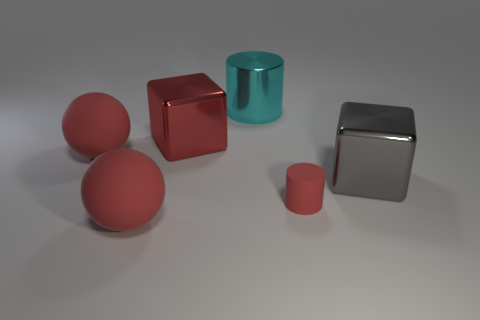What number of objects are either blocks that are to the right of the big cyan cylinder or metal things that are on the left side of the red cylinder?
Provide a succinct answer. 3. Does the cylinder behind the small red cylinder have the same material as the big red block?
Provide a succinct answer. Yes. There is a large red object that is to the left of the red metal thing and behind the large gray metal object; what is its material?
Your answer should be compact. Rubber. There is a large block in front of the big rubber ball behind the gray thing; what color is it?
Offer a terse response. Gray. What material is the gray object that is the same shape as the big red shiny thing?
Ensure brevity in your answer.  Metal. What color is the metal thing in front of the block that is behind the matte object behind the small matte thing?
Make the answer very short. Gray. What number of objects are gray metal blocks or red shiny cubes?
Your answer should be compact. 2. How many tiny red matte things have the same shape as the cyan metallic thing?
Provide a short and direct response. 1. Is the material of the gray object the same as the red object that is in front of the small cylinder?
Make the answer very short. No. There is a gray object that is made of the same material as the large cyan thing; what is its size?
Your answer should be compact. Large. 